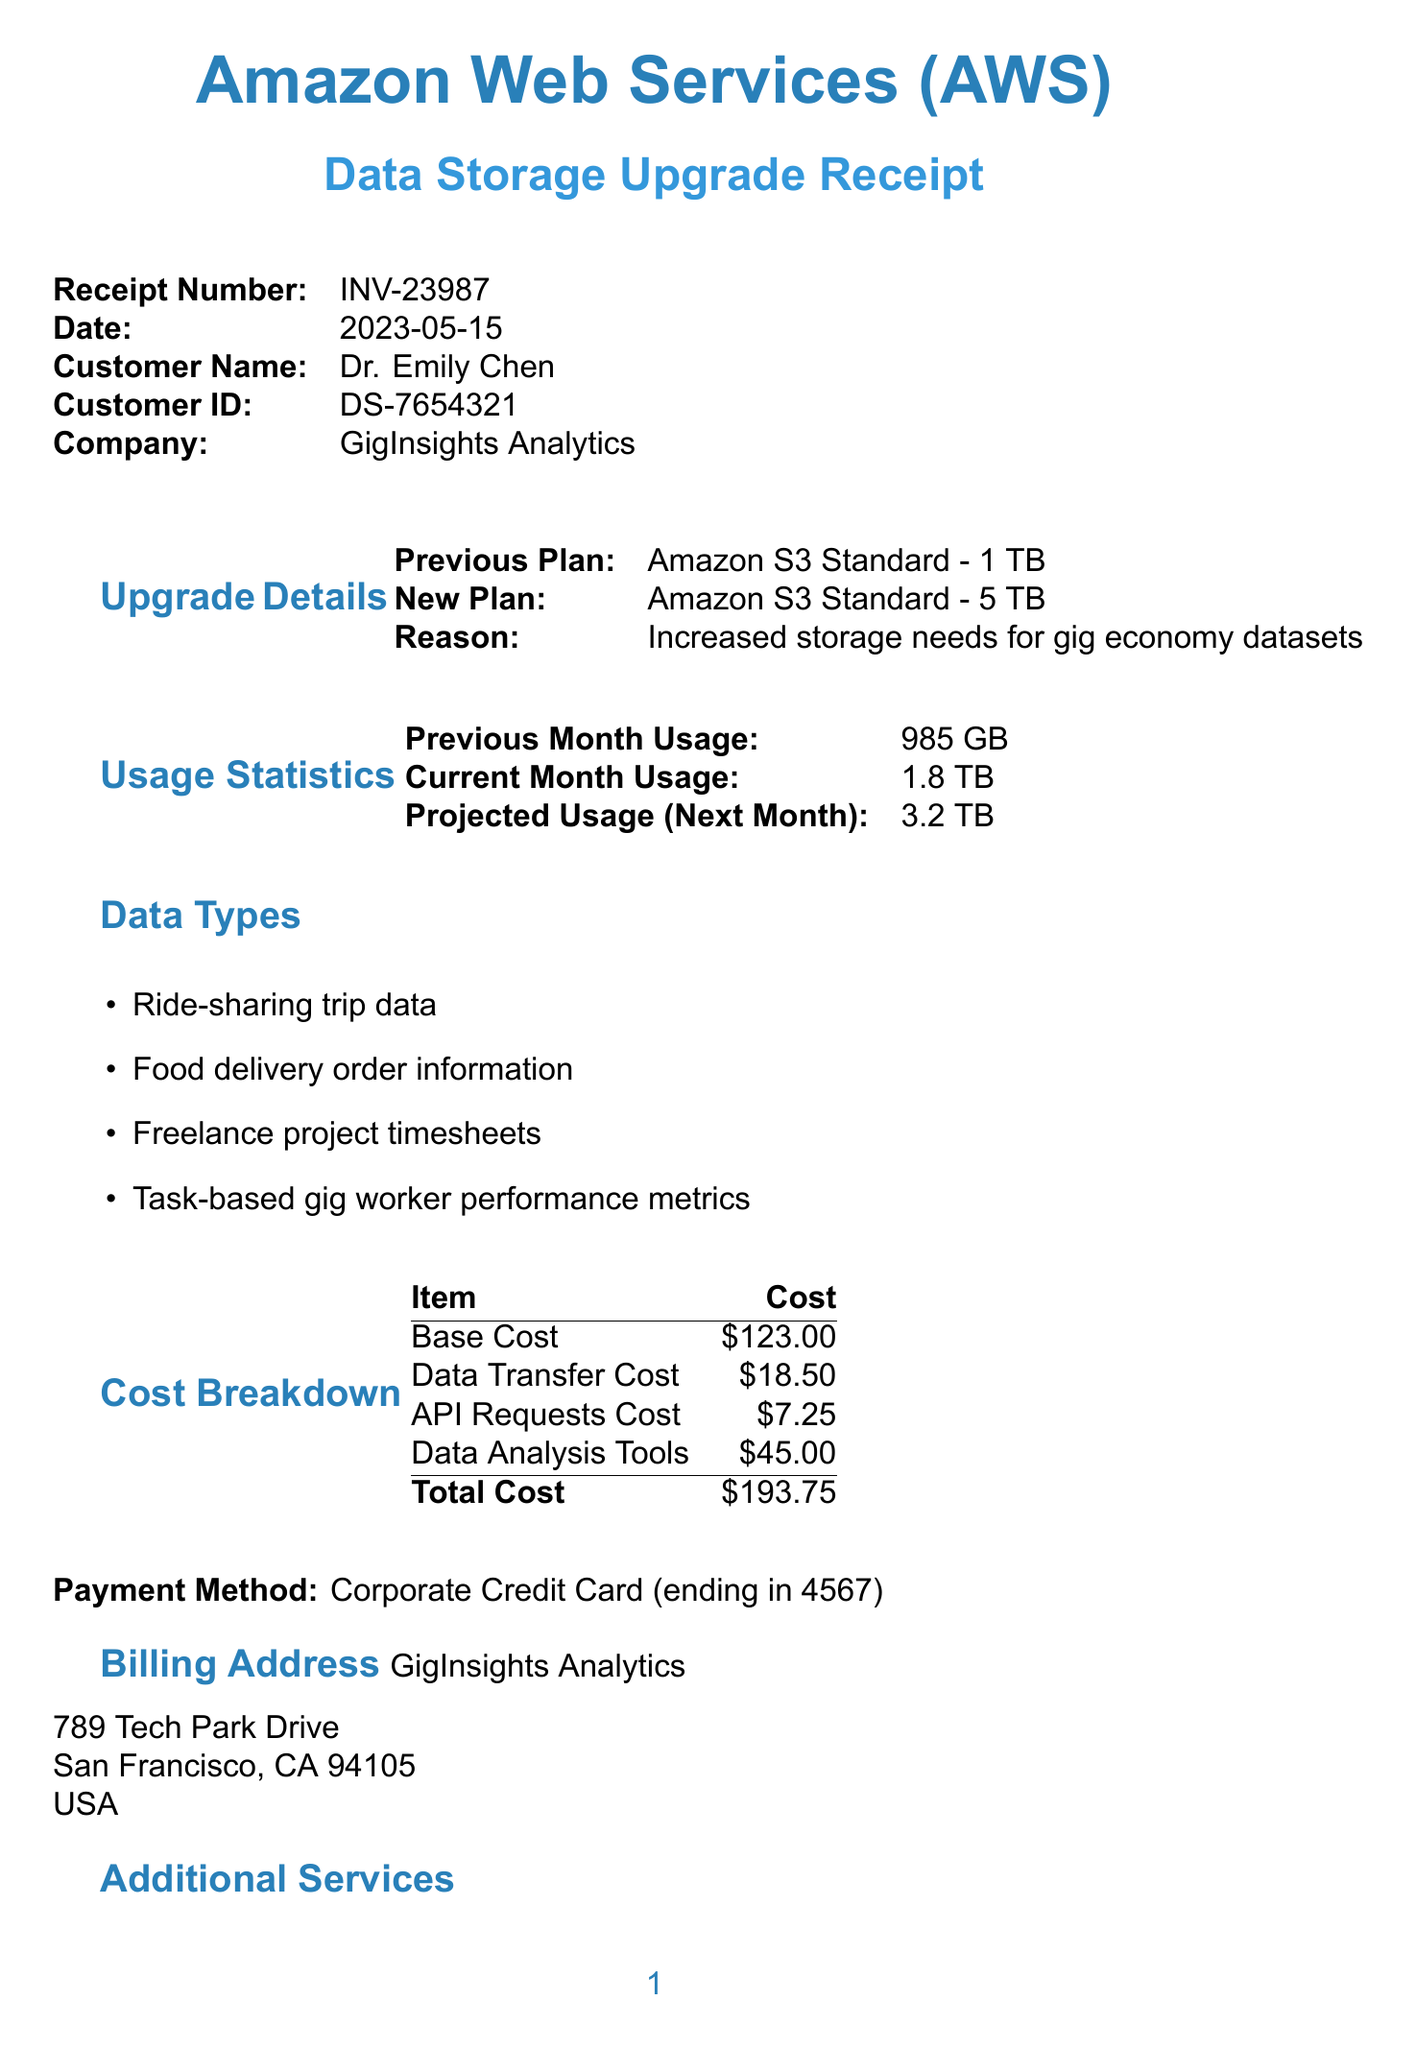What is the receipt number? The receipt number is listed at the top of the document under 'Receipt Number'.
Answer: INV-23987 What is the date of the receipt? The date is specified in the document under 'Date'.
Answer: 2023-05-15 Who is the customer? The document states the name of the customer in the section for customer details.
Answer: Dr. Emily Chen What is the reason for the upgrade? The reason for the upgrade can be found in the 'Upgrade Details' section of the document.
Answer: Increased storage needs for gig economy datasets What is the total cost for the upgrade? The total cost is provided at the end of the 'Cost Breakdown' section.
Answer: $193.75 What is the current month usage? The current month usage is specified in the 'Usage Statistics' section.
Answer: 1.8 TB What additional services are mentioned? The document lists additional services in the 'Additional Services' section.
Answer: Amazon Athena for SQL queries on S3 data, AWS Glue for ETL jobs, Amazon QuickSight for data visualization What is the next billing date? The next billing date can be found at the bottom of the document under 'Next Billing Date'.
Answer: 2023-06-15 What payment method was used? The payment method is specified in the document and is found directly after the cost breakdown.
Answer: Corporate Credit Card (ending in 4567) 